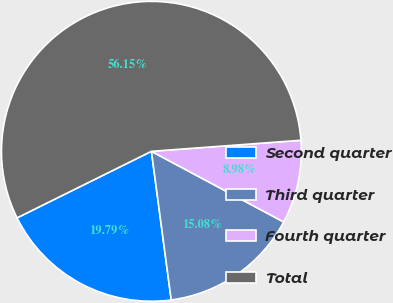Convert chart to OTSL. <chart><loc_0><loc_0><loc_500><loc_500><pie_chart><fcel>Second quarter<fcel>Third quarter<fcel>Fourth quarter<fcel>Total<nl><fcel>19.79%<fcel>15.08%<fcel>8.98%<fcel>56.14%<nl></chart> 